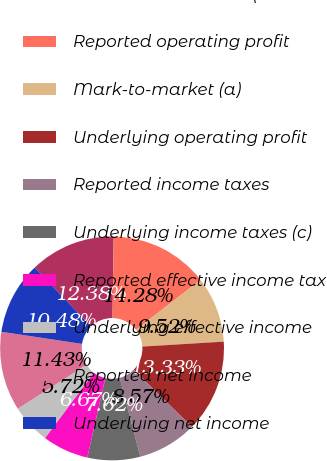Convert chart. <chart><loc_0><loc_0><loc_500><loc_500><pie_chart><fcel>Consolidated results (dollars<fcel>Reported operating profit<fcel>Mark-to-market (a)<fcel>Underlying operating profit<fcel>Reported income taxes<fcel>Underlying income taxes (c)<fcel>Reported effective income tax<fcel>Underlying effective income<fcel>Reported net income<fcel>Underlying net income<nl><fcel>12.38%<fcel>14.28%<fcel>9.52%<fcel>13.33%<fcel>8.57%<fcel>7.62%<fcel>6.67%<fcel>5.72%<fcel>11.43%<fcel>10.48%<nl></chart> 